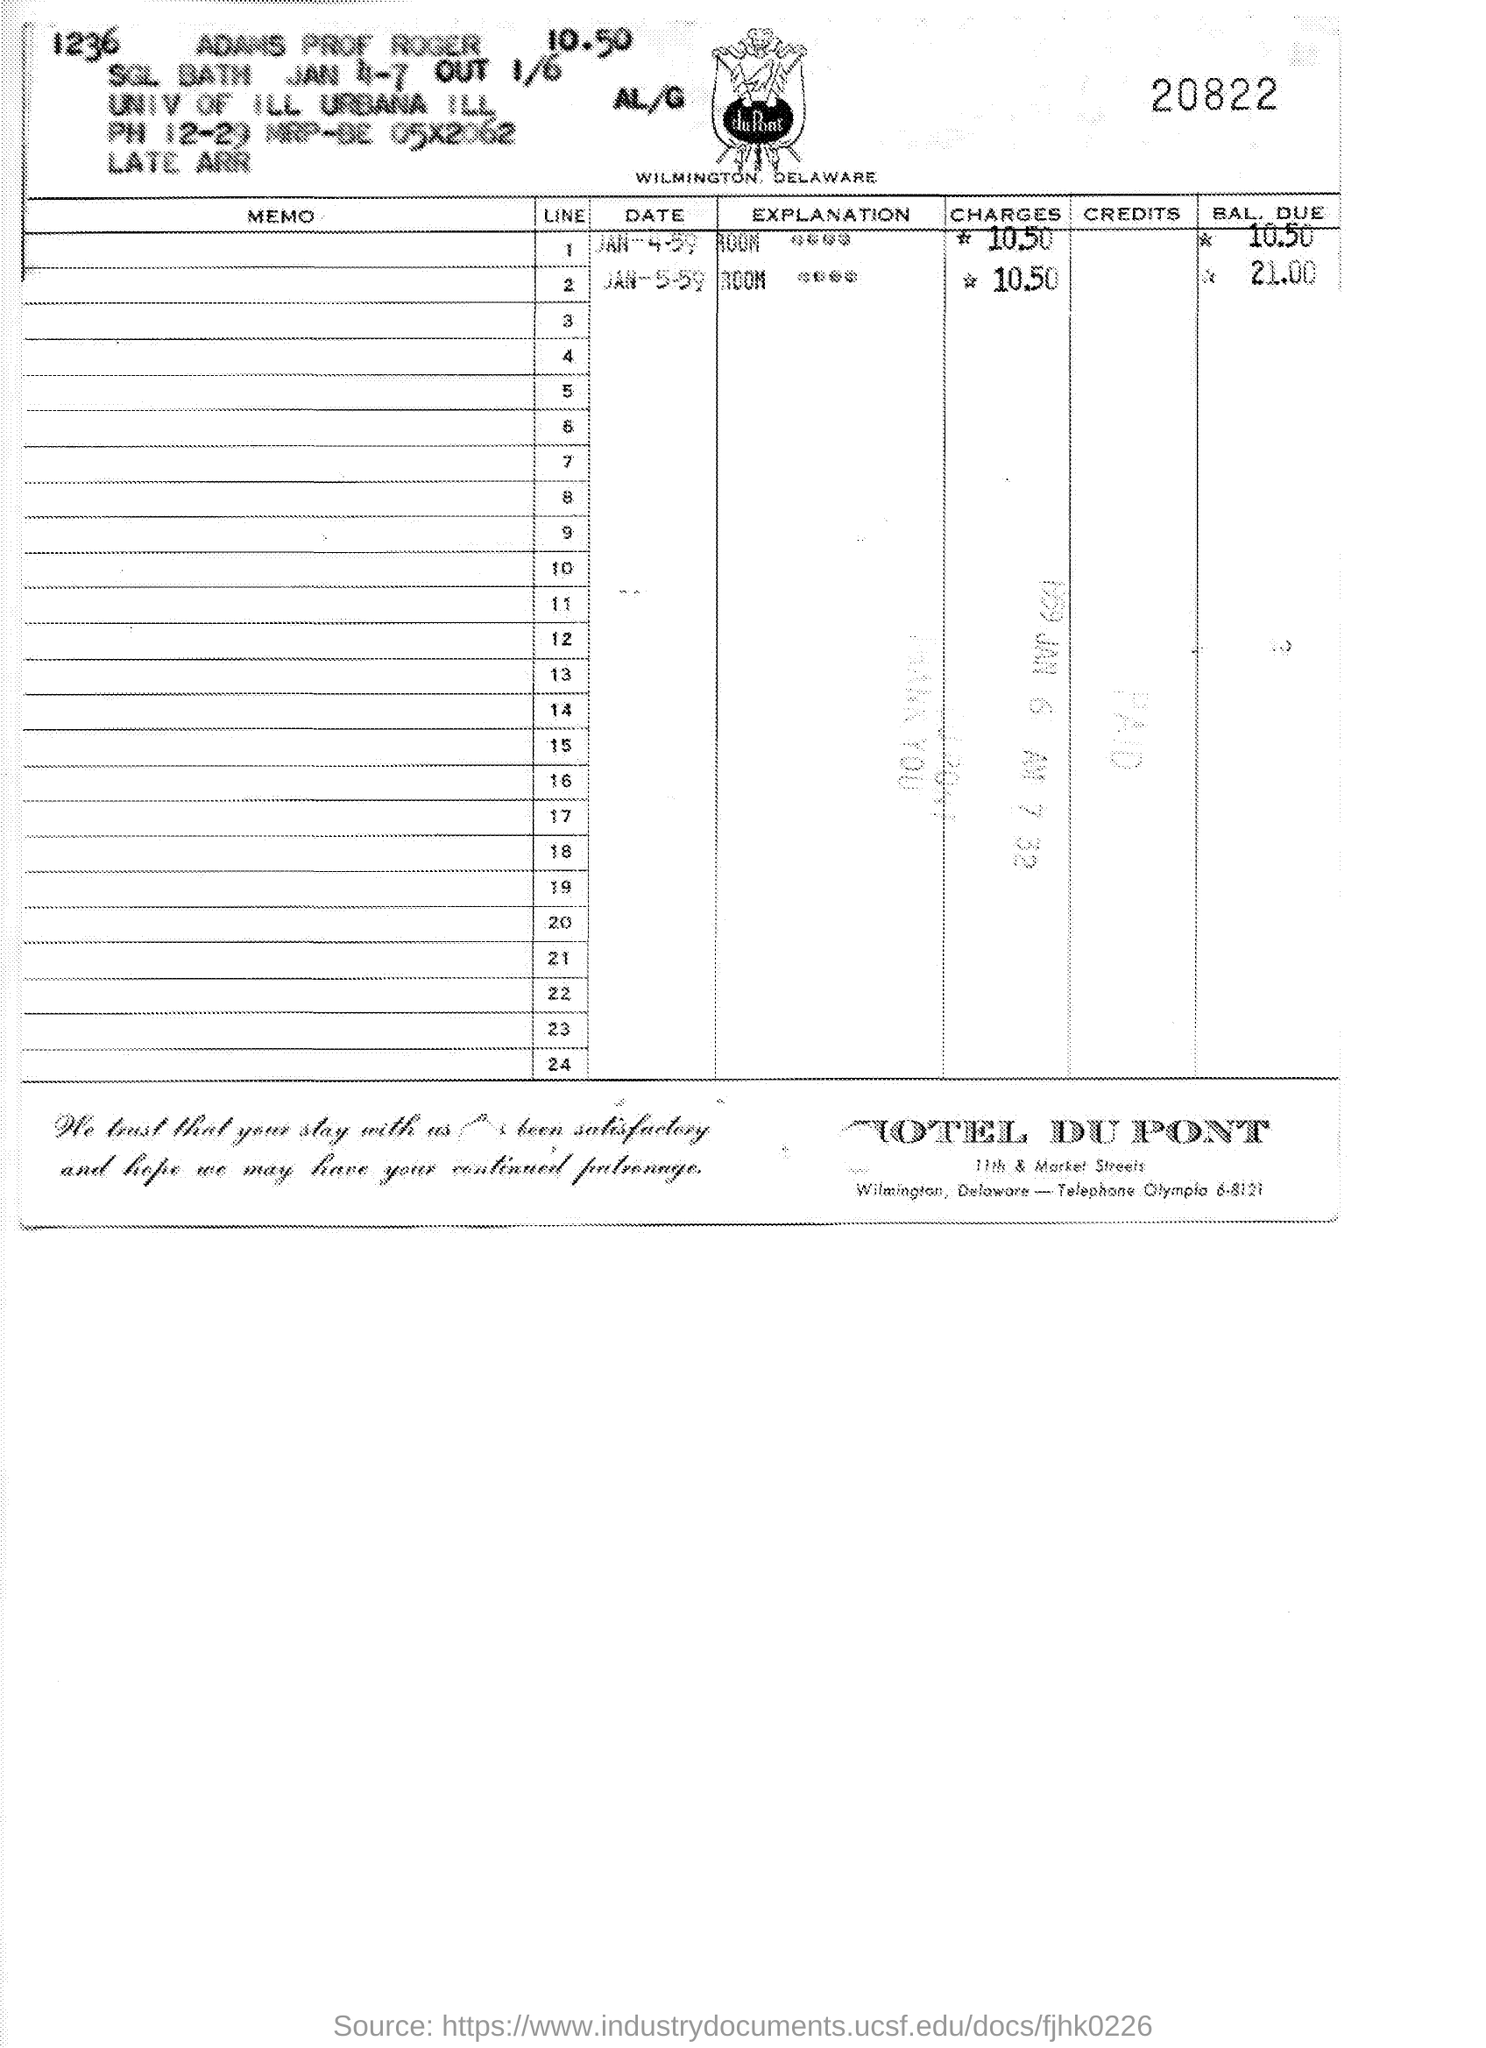Which hotel is mentioned?
Your response must be concise. HOTEL DU PONT. What is the number written at the top right of the page?
Make the answer very short. 20822. What is the balance due on JAN-5-59?
Your answer should be compact. *   21.00. 